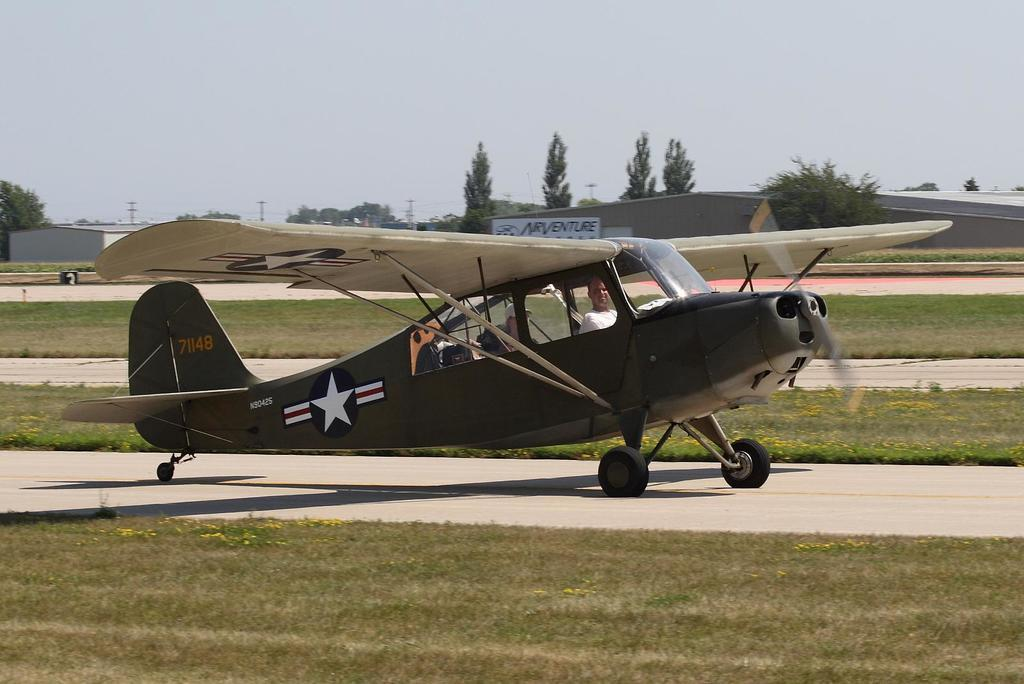What is the unusual object located on the road in the image? There is an aircraft on the road in the image. What type of vegetation can be seen in the image? There is green grass visible in the image. What can be seen in the background of the image? There are trees in the background of the image. What is visible in the sky in the image? Clouds are present in the sky in the image. What type of guitar is being played on the desk in the image? There is no guitar or desk present in the image. What type of fog can be seen in the image? There is no fog present in the image; it features an aircraft on the road, green grass, trees in the background, and clouds in the sky. 